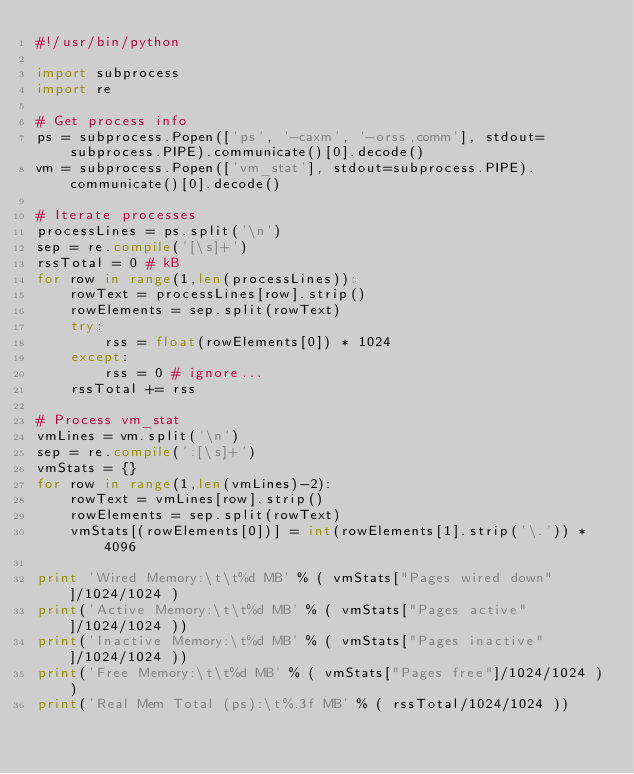<code> <loc_0><loc_0><loc_500><loc_500><_Python_>#!/usr/bin/python

import subprocess
import re

# Get process info
ps = subprocess.Popen(['ps', '-caxm', '-orss,comm'], stdout=subprocess.PIPE).communicate()[0].decode()
vm = subprocess.Popen(['vm_stat'], stdout=subprocess.PIPE).communicate()[0].decode()

# Iterate processes
processLines = ps.split('\n')
sep = re.compile('[\s]+')
rssTotal = 0 # kB
for row in range(1,len(processLines)):
    rowText = processLines[row].strip()
    rowElements = sep.split(rowText)
    try:
        rss = float(rowElements[0]) * 1024
    except:
        rss = 0 # ignore...
    rssTotal += rss

# Process vm_stat
vmLines = vm.split('\n')
sep = re.compile(':[\s]+')
vmStats = {}
for row in range(1,len(vmLines)-2):
    rowText = vmLines[row].strip()
    rowElements = sep.split(rowText)
    vmStats[(rowElements[0])] = int(rowElements[1].strip('\.')) * 4096

print 'Wired Memory:\t\t%d MB' % ( vmStats["Pages wired down"]/1024/1024 )
print('Active Memory:\t\t%d MB' % ( vmStats["Pages active"]/1024/1024 ))
print('Inactive Memory:\t%d MB' % ( vmStats["Pages inactive"]/1024/1024 ))
print('Free Memory:\t\t%d MB' % ( vmStats["Pages free"]/1024/1024 ))
print('Real Mem Total (ps):\t%.3f MB' % ( rssTotal/1024/1024 ))
</code> 